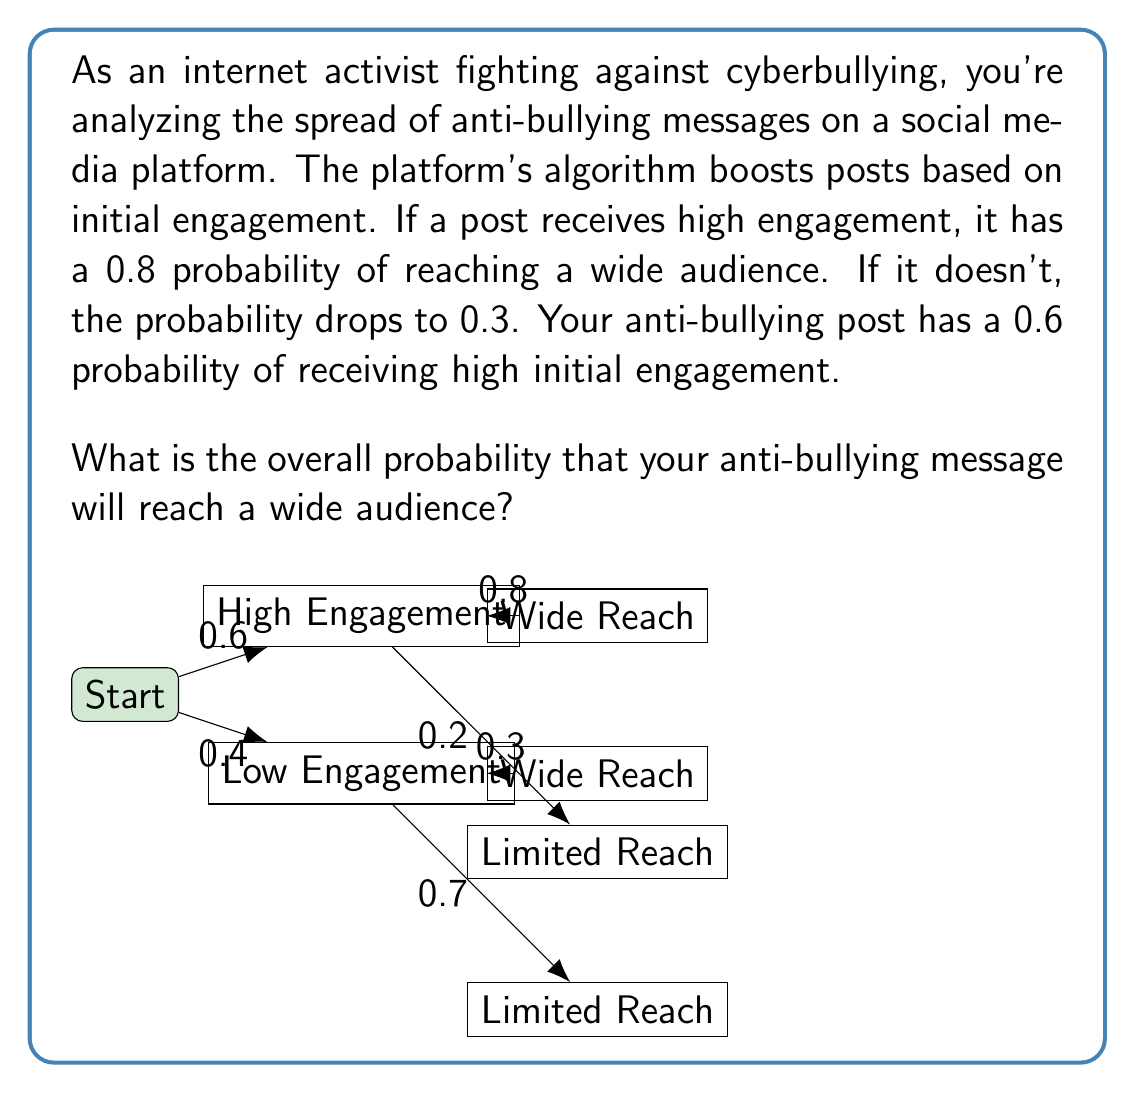Help me with this question. Let's approach this step-by-step using the law of total probability:

1) Define events:
   A: The post reaches a wide audience
   B: The post receives high initial engagement

2) Given probabilities:
   P(B) = 0.6 (probability of high engagement)
   P(A|B) = 0.8 (probability of wide reach given high engagement)
   P(A|not B) = 0.3 (probability of wide reach given low engagement)

3) The law of total probability states:
   P(A) = P(A|B) * P(B) + P(A|not B) * P(not B)

4) Calculate P(not B):
   P(not B) = 1 - P(B) = 1 - 0.6 = 0.4

5) Apply the formula:
   P(A) = 0.8 * 0.6 + 0.3 * 0.4

6) Calculate:
   P(A) = 0.48 + 0.12 = 0.6

Therefore, the overall probability that the anti-bullying message will reach a wide audience is 0.6 or 60%.
Answer: 0.6 